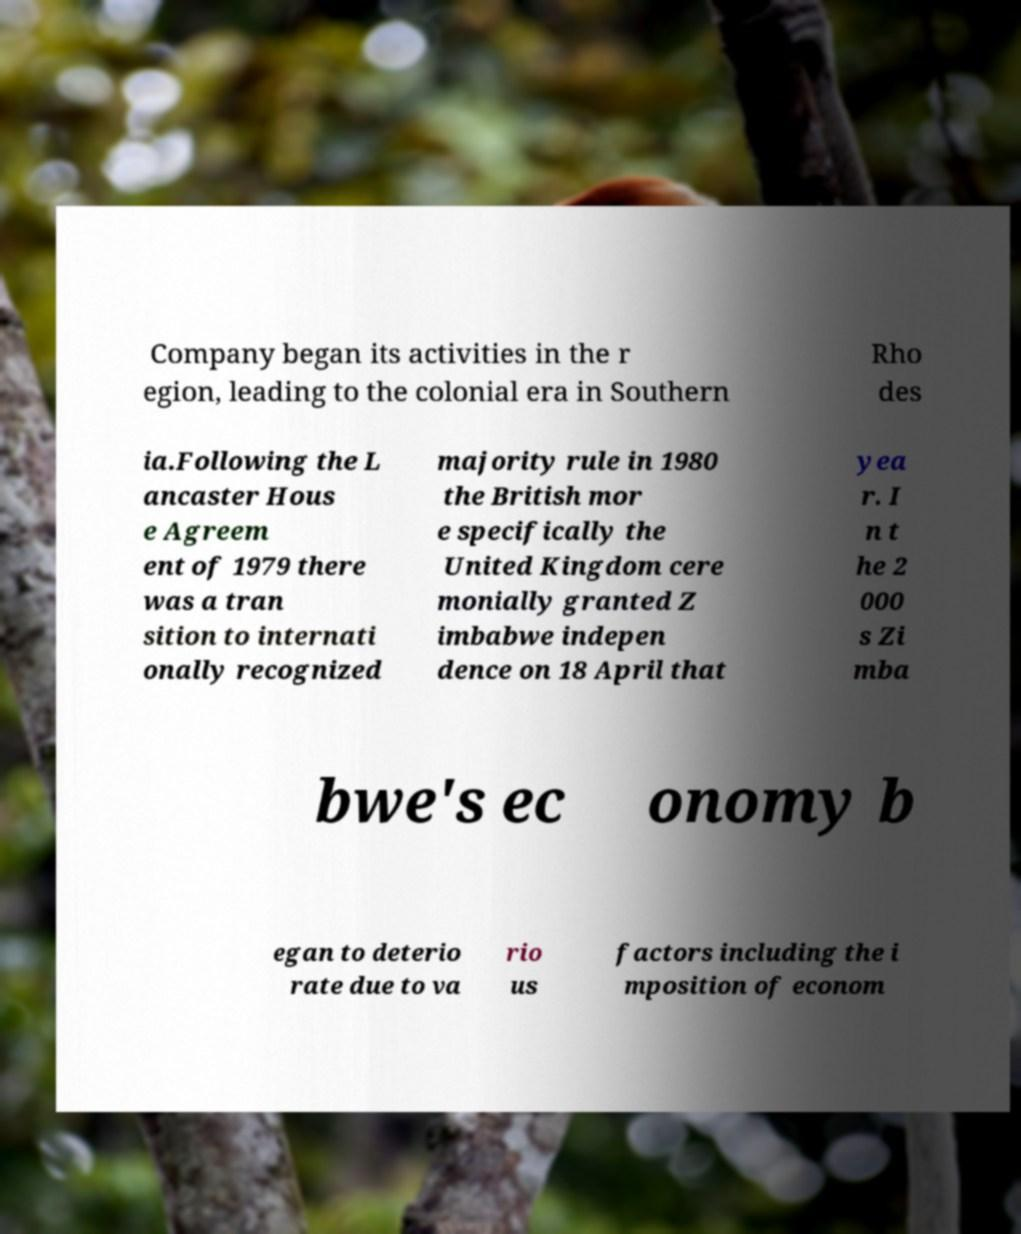Can you accurately transcribe the text from the provided image for me? Company began its activities in the r egion, leading to the colonial era in Southern Rho des ia.Following the L ancaster Hous e Agreem ent of 1979 there was a tran sition to internati onally recognized majority rule in 1980 the British mor e specifically the United Kingdom cere monially granted Z imbabwe indepen dence on 18 April that yea r. I n t he 2 000 s Zi mba bwe's ec onomy b egan to deterio rate due to va rio us factors including the i mposition of econom 